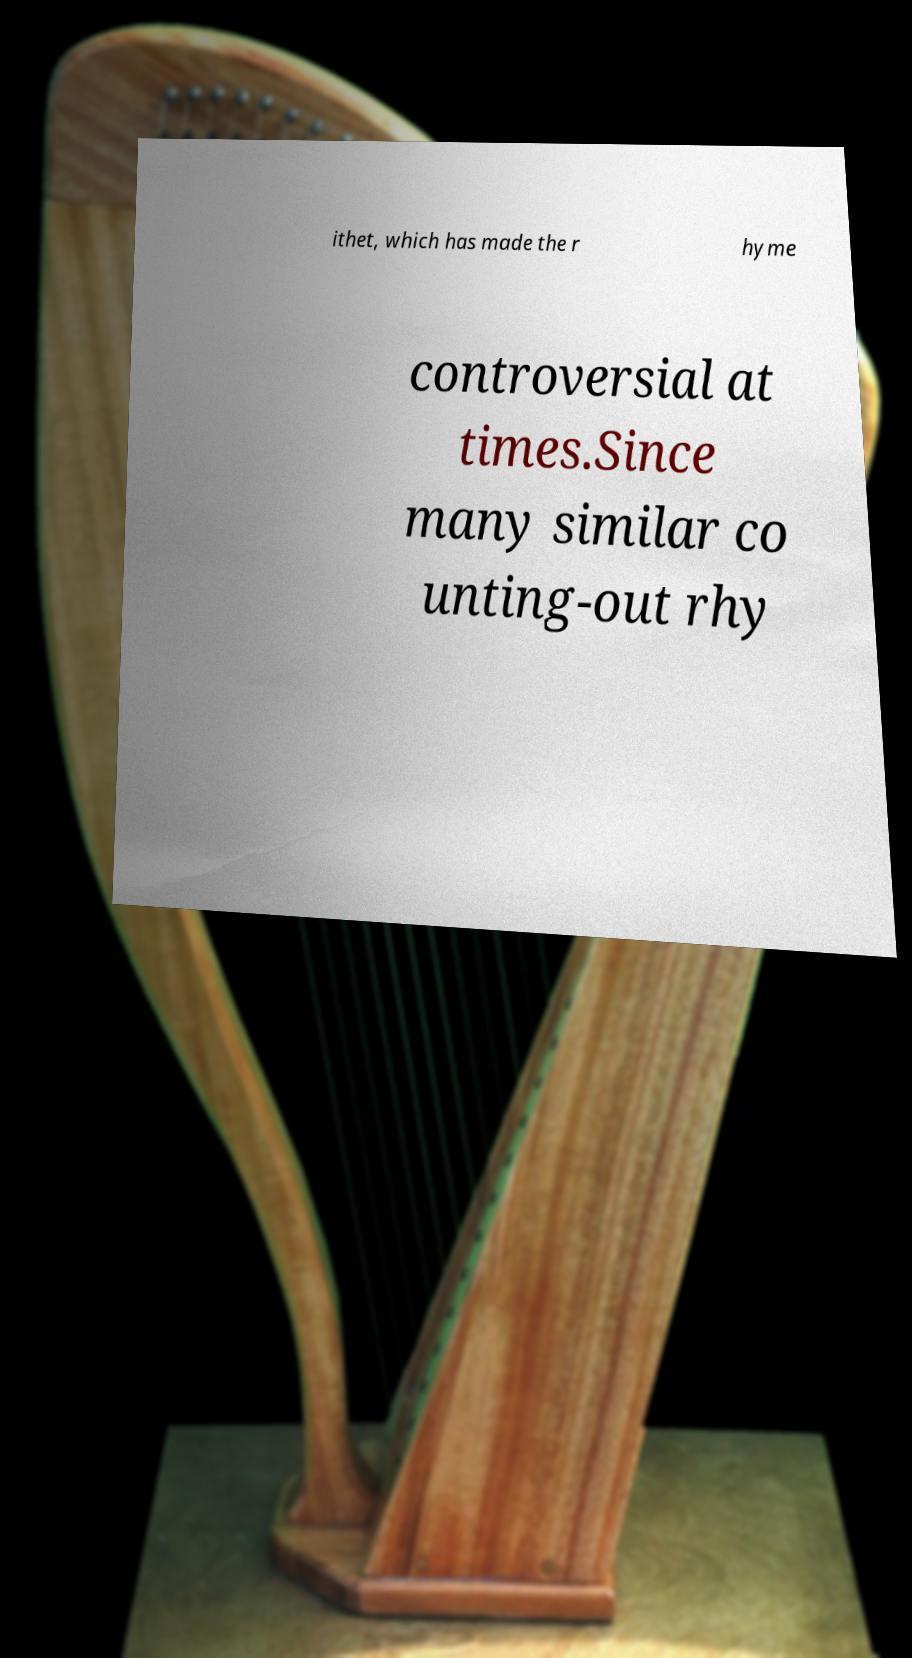There's text embedded in this image that I need extracted. Can you transcribe it verbatim? ithet, which has made the r hyme controversial at times.Since many similar co unting-out rhy 